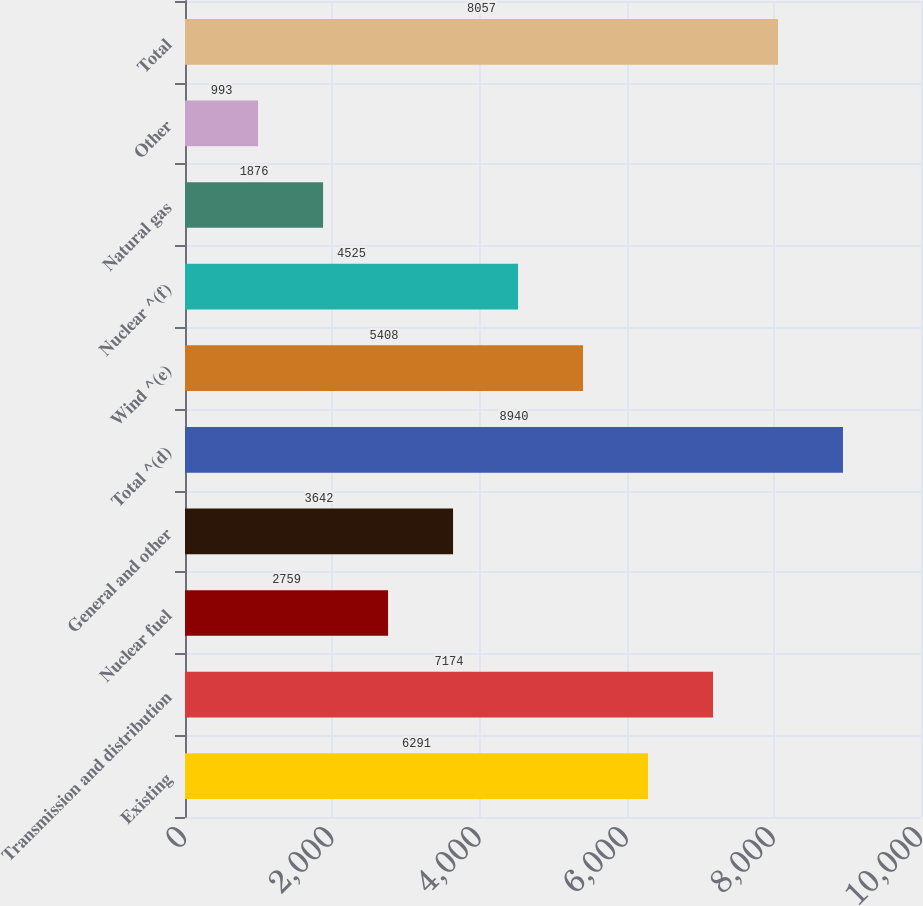<chart> <loc_0><loc_0><loc_500><loc_500><bar_chart><fcel>Existing<fcel>Transmission and distribution<fcel>Nuclear fuel<fcel>General and other<fcel>Total ^(d)<fcel>Wind ^(e)<fcel>Nuclear ^(f)<fcel>Natural gas<fcel>Other<fcel>Total<nl><fcel>6291<fcel>7174<fcel>2759<fcel>3642<fcel>8940<fcel>5408<fcel>4525<fcel>1876<fcel>993<fcel>8057<nl></chart> 